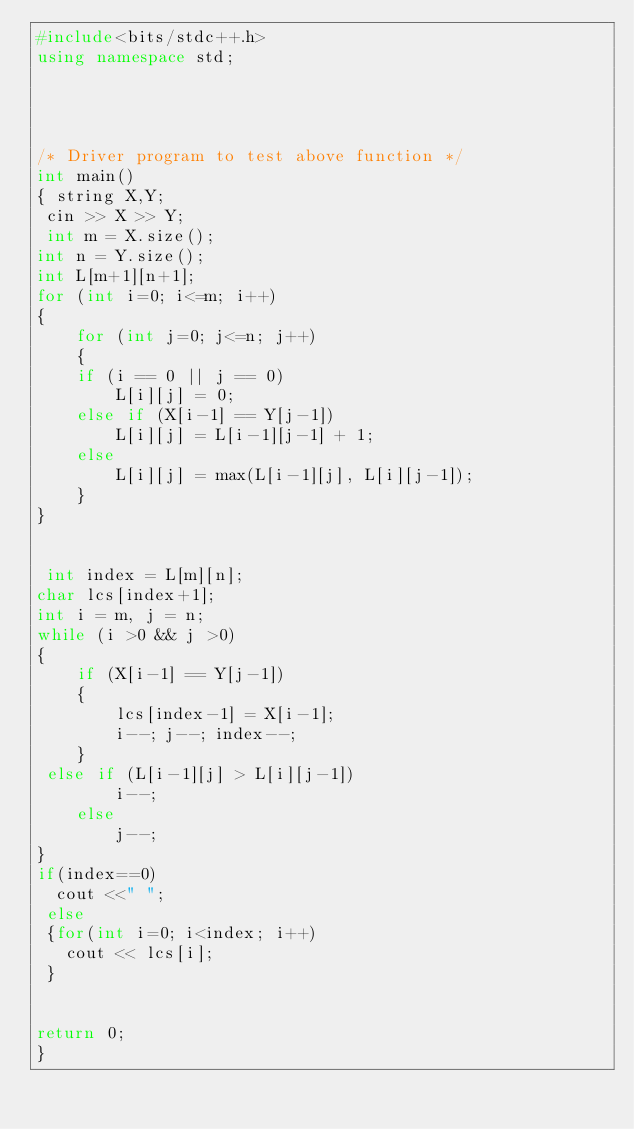<code> <loc_0><loc_0><loc_500><loc_500><_C++_>#include<bits/stdc++.h>
using namespace std; 

 
 

/* Driver program to test above function */
int main() 
{ string X,Y;
 cin >> X >> Y;
 int m = X.size(); 
int n = Y.size();
int L[m+1][n+1]; 
for (int i=0; i<=m; i++) 
{ 
	for (int j=0; j<=n; j++) 
	{ 
	if (i == 0 || j == 0) 
		L[i][j] = 0; 
	else if (X[i-1] == Y[j-1]) 
		L[i][j] = L[i-1][j-1] + 1; 
	else
		L[i][j] = max(L[i-1][j], L[i][j-1]); 
	} 
} 

 
 int index = L[m][n]; 
char lcs[index+1];
int i = m, j = n; 
while (i >0 && j >0) 
{ 
	if (X[i-1] == Y[j-1]) 
	{ 
		lcs[index-1] = X[i-1];  
		i--; j--; index--;	 
	} 
 else if (L[i-1][j] > L[i][j-1]) 
		i--; 
	else
		j--; 
}
if(index==0)
  cout <<" ";
 else 
 {for(int i=0; i<index; i++)
   cout << lcs[i];
 }
 
 
return 0; 
} 
</code> 